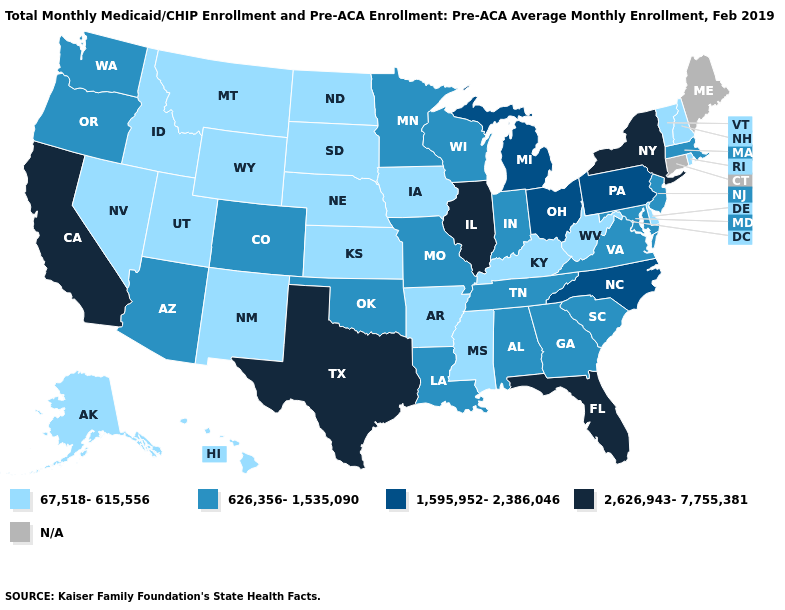Does California have the highest value in the USA?
Quick response, please. Yes. What is the lowest value in the USA?
Keep it brief. 67,518-615,556. What is the value of Florida?
Short answer required. 2,626,943-7,755,381. Name the states that have a value in the range 67,518-615,556?
Answer briefly. Alaska, Arkansas, Delaware, Hawaii, Idaho, Iowa, Kansas, Kentucky, Mississippi, Montana, Nebraska, Nevada, New Hampshire, New Mexico, North Dakota, Rhode Island, South Dakota, Utah, Vermont, West Virginia, Wyoming. Which states have the lowest value in the South?
Quick response, please. Arkansas, Delaware, Kentucky, Mississippi, West Virginia. What is the highest value in the USA?
Keep it brief. 2,626,943-7,755,381. Does the first symbol in the legend represent the smallest category?
Answer briefly. Yes. What is the value of Wisconsin?
Write a very short answer. 626,356-1,535,090. Is the legend a continuous bar?
Quick response, please. No. Name the states that have a value in the range 67,518-615,556?
Answer briefly. Alaska, Arkansas, Delaware, Hawaii, Idaho, Iowa, Kansas, Kentucky, Mississippi, Montana, Nebraska, Nevada, New Hampshire, New Mexico, North Dakota, Rhode Island, South Dakota, Utah, Vermont, West Virginia, Wyoming. Which states have the lowest value in the USA?
Quick response, please. Alaska, Arkansas, Delaware, Hawaii, Idaho, Iowa, Kansas, Kentucky, Mississippi, Montana, Nebraska, Nevada, New Hampshire, New Mexico, North Dakota, Rhode Island, South Dakota, Utah, Vermont, West Virginia, Wyoming. What is the value of Rhode Island?
Keep it brief. 67,518-615,556. Name the states that have a value in the range 67,518-615,556?
Concise answer only. Alaska, Arkansas, Delaware, Hawaii, Idaho, Iowa, Kansas, Kentucky, Mississippi, Montana, Nebraska, Nevada, New Hampshire, New Mexico, North Dakota, Rhode Island, South Dakota, Utah, Vermont, West Virginia, Wyoming. 